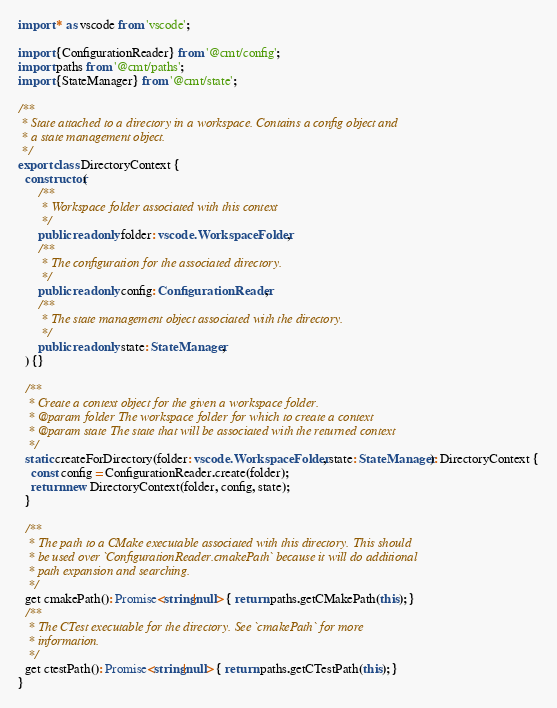<code> <loc_0><loc_0><loc_500><loc_500><_TypeScript_>import * as vscode from 'vscode';

import {ConfigurationReader} from '@cmt/config';
import paths from '@cmt/paths';
import {StateManager} from '@cmt/state';

/**
 * State attached to a directory in a workspace. Contains a config object and
 * a state management object.
 */
export class DirectoryContext {
  constructor(
      /**
       * Workspace folder associated with this context
       */
      public readonly folder: vscode.WorkspaceFolder,
      /**
       * The configuration for the associated directory.
       */
      public readonly config: ConfigurationReader,
      /**
       * The state management object associated with the directory.
       */
      public readonly state: StateManager,
  ) {}

  /**
   * Create a context object for the given a workspace folder.
   * @param folder The workspace folder for which to create a context
   * @param state The state that will be associated with the returned context
   */
  static createForDirectory(folder: vscode.WorkspaceFolder, state: StateManager): DirectoryContext {
    const config = ConfigurationReader.create(folder);
    return new DirectoryContext(folder, config, state);
  }

  /**
   * The path to a CMake executable associated with this directory. This should
   * be used over `ConfigurationReader.cmakePath` because it will do additional
   * path expansion and searching.
   */
  get cmakePath(): Promise<string|null> { return paths.getCMakePath(this); }
  /**
   * The CTest executable for the directory. See `cmakePath` for more
   * information.
   */
  get ctestPath(): Promise<string|null> { return paths.getCTestPath(this); }
}</code> 